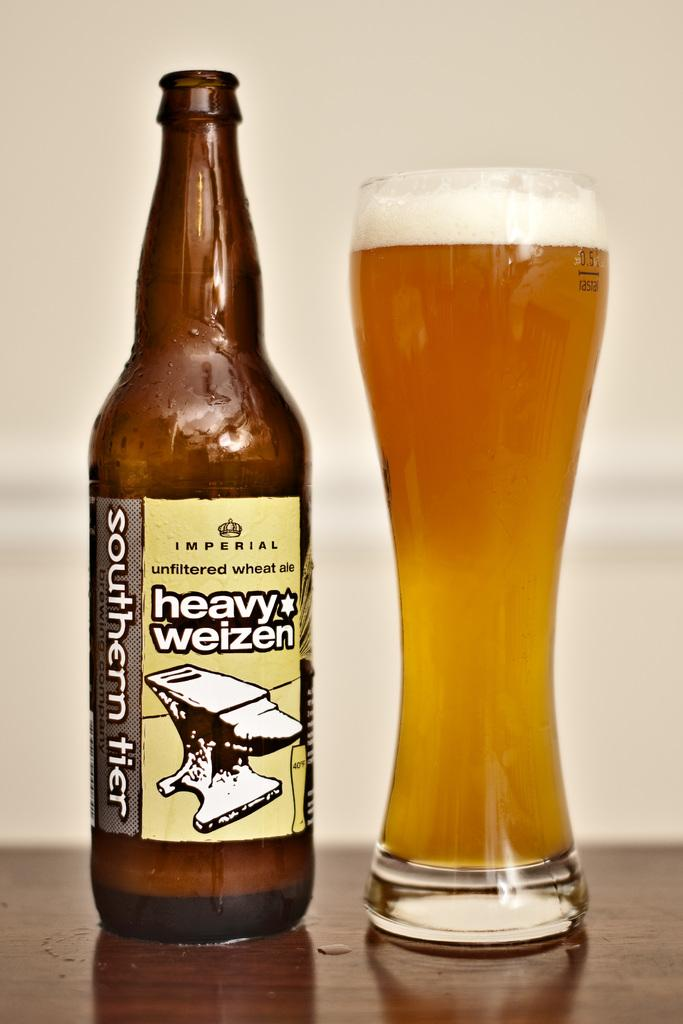What can be seen in the image related to alcoholic beverages? There is a beer bottle and a beer glass in the image. What is the label on the beer bottle? The beer bottle has a label attached to it. How much beer is in the glass? The beer glass is full of beer. Where are the beer bottle and glass located in the image? The beer bottle and glass are placed on a table. What type of jellyfish can be seen swimming in the beer glass in the image? There are no jellyfish present in the image; it features a beer bottle and glass on a table. What part of the person's face is visible in the image? There is no person present in the image, so no facial features can be observed. 